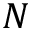<formula> <loc_0><loc_0><loc_500><loc_500>N</formula> 